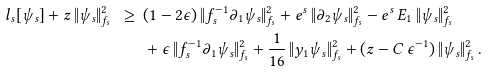Convert formula to latex. <formula><loc_0><loc_0><loc_500><loc_500>l _ { s } [ \psi _ { s } ] + z \, \| \psi _ { s } \| _ { f _ { s } } ^ { 2 } \ \geq \ & ( 1 - 2 \epsilon ) \, \| f _ { s } ^ { - 1 } \partial _ { 1 } \psi _ { s } \| _ { f _ { s } } ^ { 2 } + e ^ { s } \, \| \partial _ { 2 } \psi _ { s } \| _ { f _ { s } } ^ { 2 } - e ^ { s } \, E _ { 1 } \, \| \psi _ { s } \| _ { f _ { s } } ^ { 2 } \\ & + \epsilon \, \| f _ { s } ^ { - 1 } \partial _ { 1 } \psi _ { s } \| _ { f _ { s } } ^ { 2 } + \frac { 1 } { 1 6 } \, \| y _ { 1 } \psi _ { s } \| _ { f _ { s } } ^ { 2 } + ( z - C \, \epsilon ^ { - 1 } ) \, \| \psi _ { s } \| _ { f _ { s } } ^ { 2 } \, .</formula> 